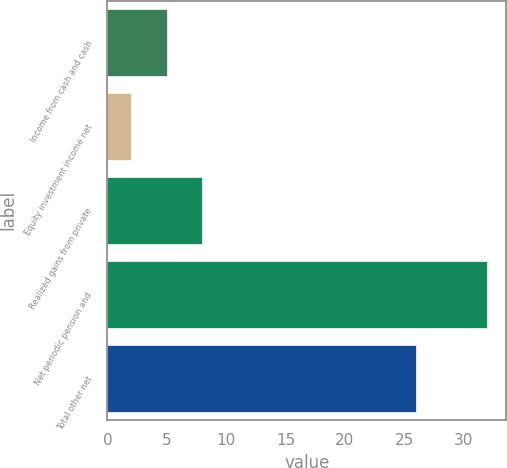Convert chart to OTSL. <chart><loc_0><loc_0><loc_500><loc_500><bar_chart><fcel>Income from cash and cash<fcel>Equity investment income net<fcel>Realized gains from private<fcel>Net periodic pension and<fcel>Total other net<nl><fcel>5<fcel>2<fcel>8<fcel>32<fcel>26<nl></chart> 